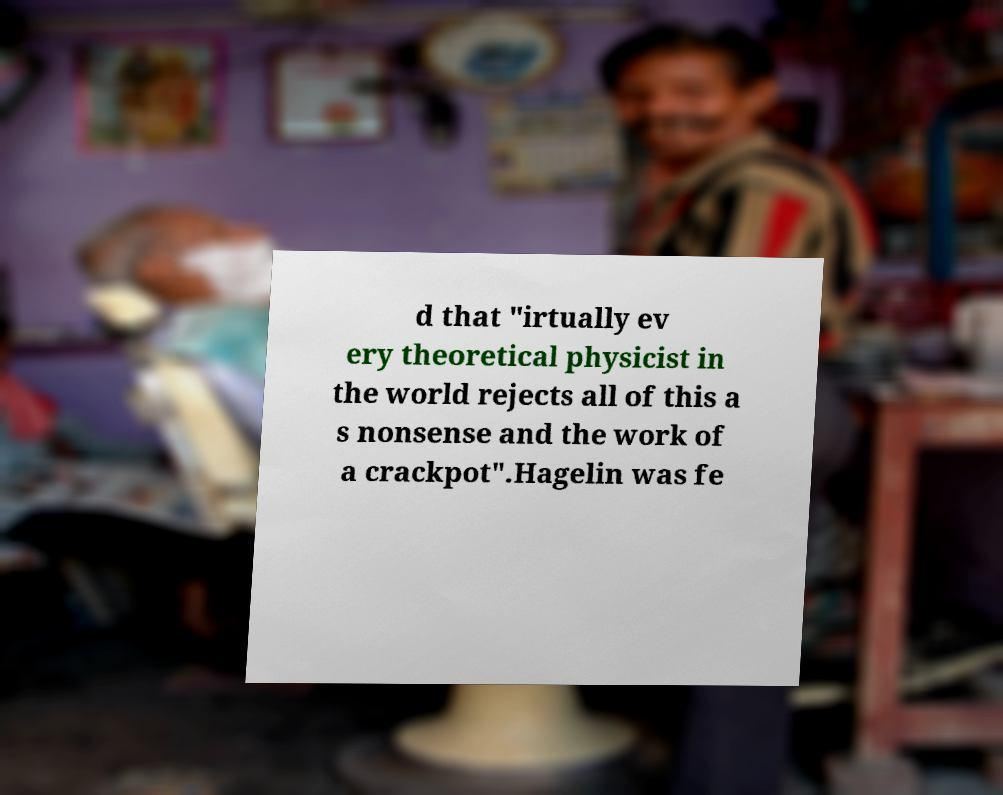Can you accurately transcribe the text from the provided image for me? d that "irtually ev ery theoretical physicist in the world rejects all of this a s nonsense and the work of a crackpot".Hagelin was fe 